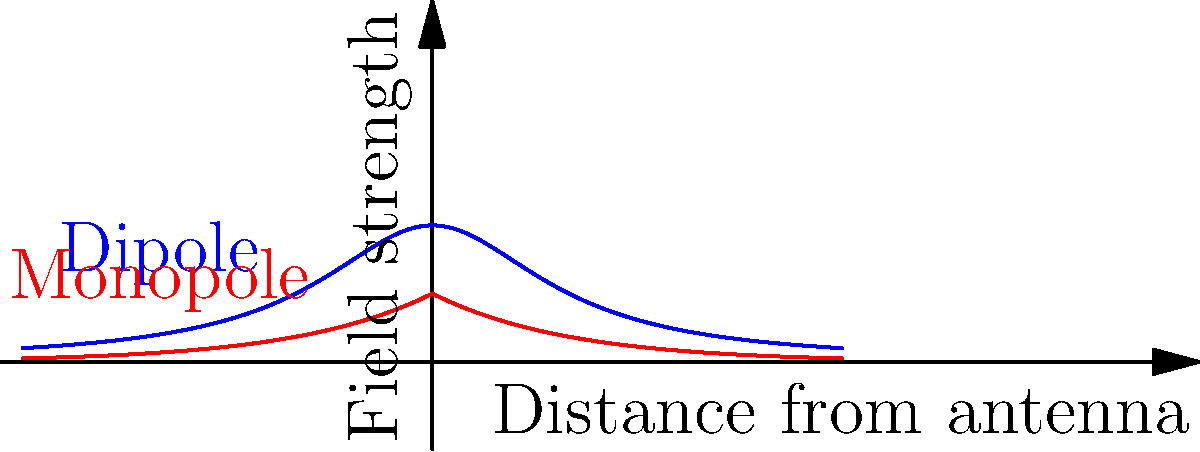In the context of Adorno's critique of mass culture and standardization, how might the difference in electromagnetic field distribution between dipole and monopole antennas, as shown in the graph, be interpreted as a metaphor for cultural homogenization versus diversity? Consider the implications for radio broadcasting and its impact on society. To answer this question, we need to analyze the graph and relate it to Adorno's philosophical ideas:

1. Graph interpretation:
   - The blue curve represents a dipole antenna's field distribution.
   - The red curve represents a monopole antenna's field distribution.
   - The x-axis shows the distance from the antenna, and the y-axis shows the field strength.

2. Adorno's critique of mass culture:
   - Adorno was critical of the standardization and homogenization of culture by mass media.
   - He argued that mass culture leads to a loss of individuality and critical thinking.

3. Antenna types as cultural metaphors:
   - Dipole antenna (blue curve):
     - Broader, more uniform distribution
     - Can be seen as representing standardization and homogenization
   - Monopole antenna (red curve):
     - More concentrated near the source, rapidly decreasing with distance
     - Can be interpreted as representing diversity and localization

4. Implications for radio broadcasting:
   - Dipole antennas might represent widespread, uniform cultural dissemination.
   - Monopole antennas could symbolize more localized, diverse cultural expressions.

5. Societal impact:
   - The choice of antenna type could be seen as a reflection of cultural policy.
   - Widespread use of dipole antennas might lead to cultural homogenization.
   - Monopole antennas could promote cultural diversity but with limited reach.

6. Critical analysis:
   - The metaphor highlights the tension between reach and diversity in cultural transmission.
   - It raises questions about the role of technology in shaping cultural experiences.

By examining the electromagnetic field distributions through Adorno's philosophical lens, we can explore the complex relationship between technology, media, and cultural diversity in modern society.
Answer: The dipole antenna's uniform distribution metaphorically represents cultural homogenization, while the monopole's concentrated distribution symbolizes cultural diversity, reflecting Adorno's critique of mass culture and standardization in media. 